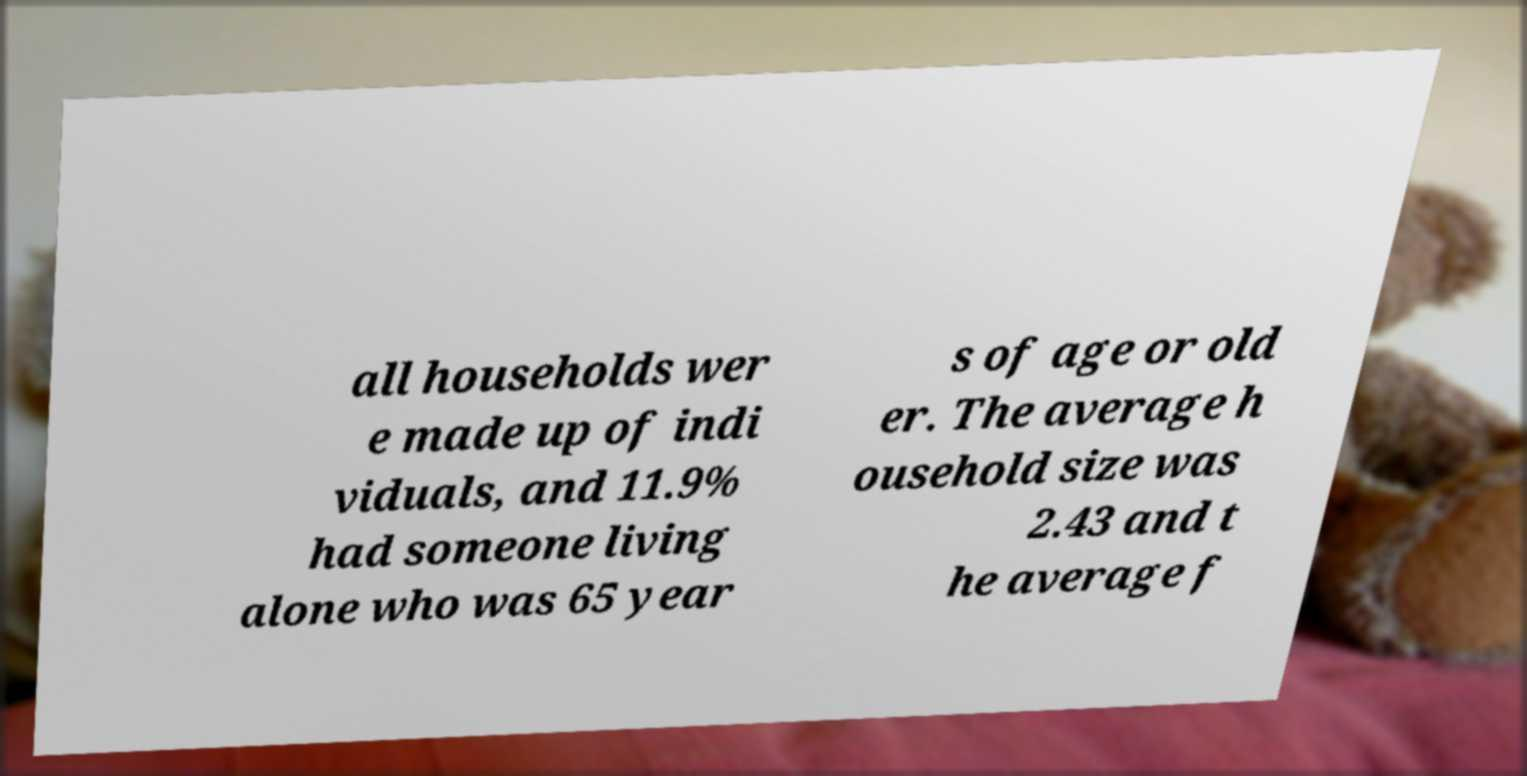There's text embedded in this image that I need extracted. Can you transcribe it verbatim? all households wer e made up of indi viduals, and 11.9% had someone living alone who was 65 year s of age or old er. The average h ousehold size was 2.43 and t he average f 